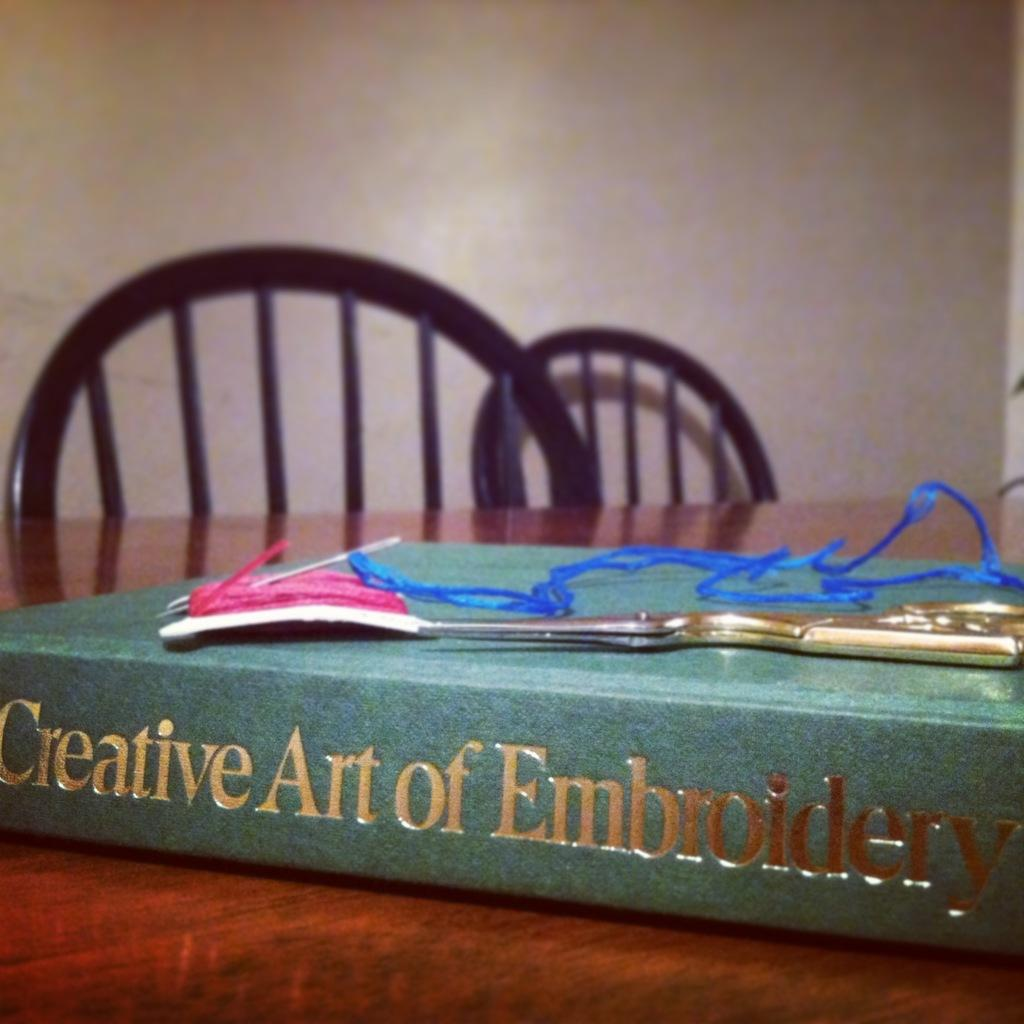Provide a one-sentence caption for the provided image. A book entitled "Creative Art of Embroidery" lays on its side on the table, with some scissors and thread on top of it. 